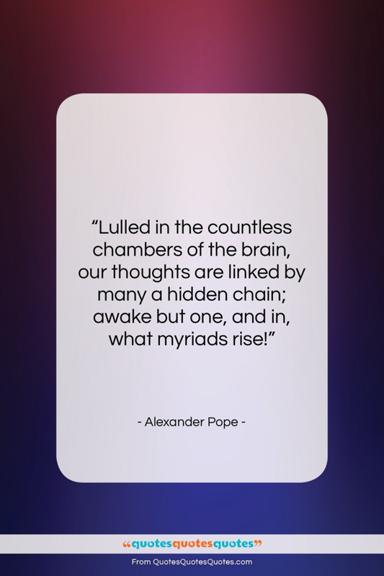What emotions does the choice of colors in the image evoke? The smooth gradient from violet to blue tends to evoke feelings of serenity and introspection. Violet is often associated with creativity and wisdom, while blue can represent peace and tranquility. The combination of these colors surrounding the white quote card suggests a contemplative space where one can ponder the depths of the human mind, as referenced in the quote. 